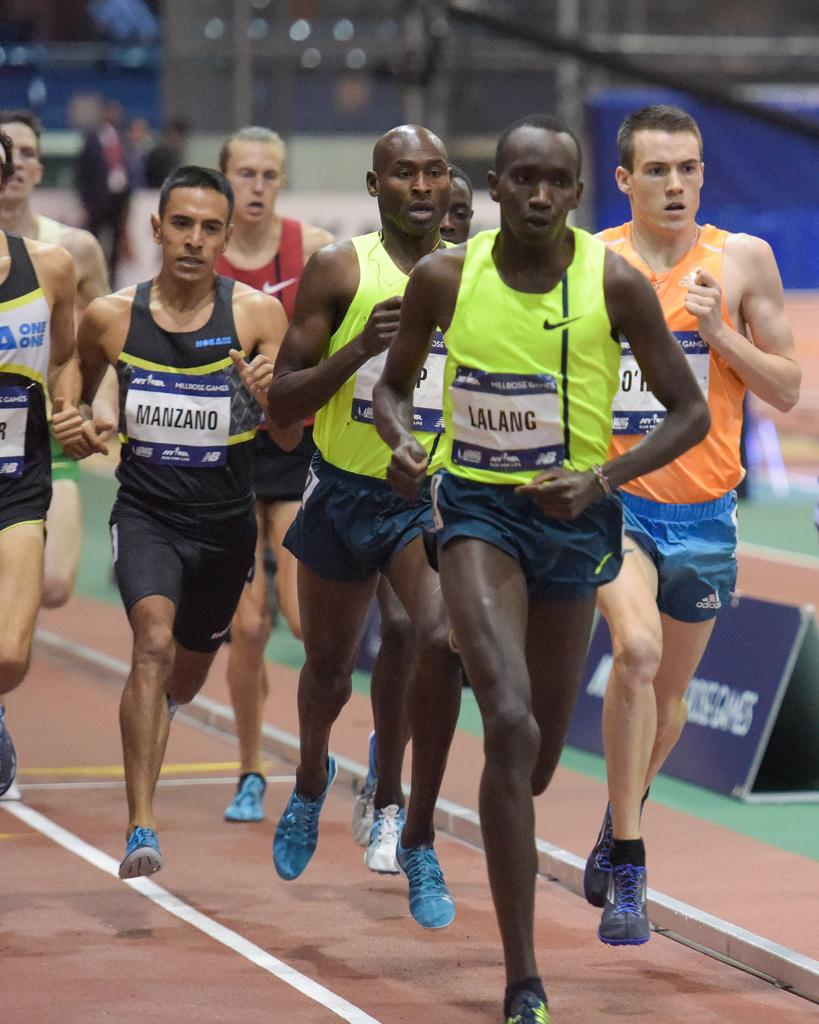Who or what is present in the image? There are people in the image. What are the people doing in the image? The people are running. Can you describe the background of the image? The background of the image is blurry. What type of footwear are the people wearing in the image? The people in the image are wearing shoes. Where is the crown located in the image? There is no crown present in the image. What type of rake is being used by the people in the image? There is no rake present in the image; the people are running. 